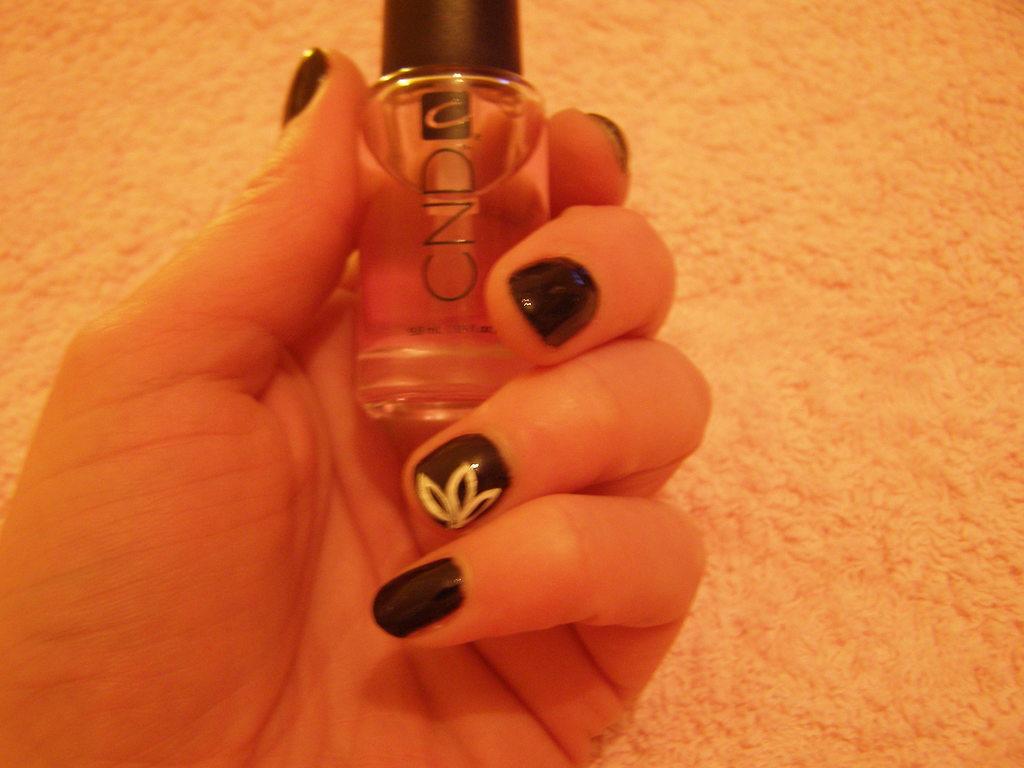What brand is this nail polish?
Provide a short and direct response. Cnd. What letter makes up the icon on the bottle?
Your response must be concise. C. 